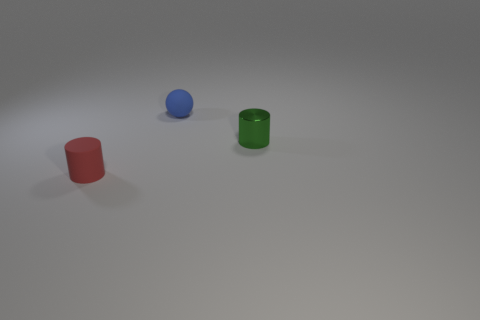Considering the shadows, where do you think the light source is coming from? Based on the shadows cast by the objects, the light source is likely positioned above and slightly to the right of the scene. 